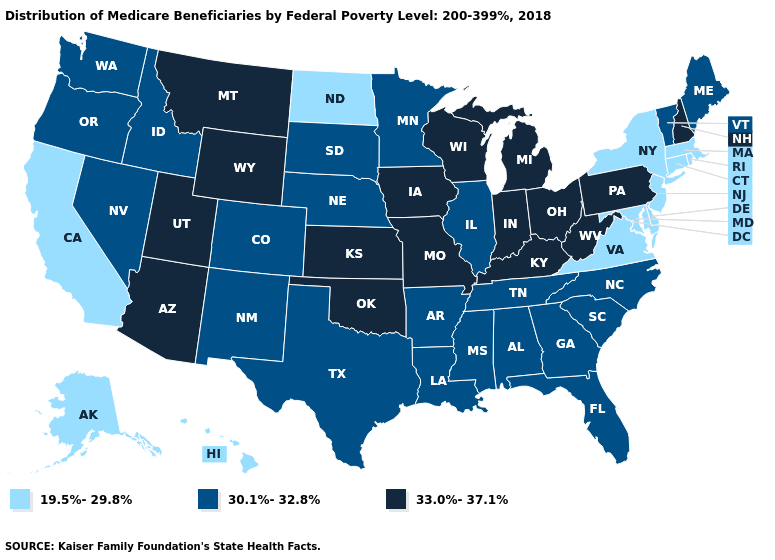Does North Dakota have the highest value in the MidWest?
Quick response, please. No. Name the states that have a value in the range 33.0%-37.1%?
Quick response, please. Arizona, Indiana, Iowa, Kansas, Kentucky, Michigan, Missouri, Montana, New Hampshire, Ohio, Oklahoma, Pennsylvania, Utah, West Virginia, Wisconsin, Wyoming. What is the value of Maryland?
Be succinct. 19.5%-29.8%. What is the value of Louisiana?
Short answer required. 30.1%-32.8%. What is the highest value in the USA?
Write a very short answer. 33.0%-37.1%. What is the value of Delaware?
Answer briefly. 19.5%-29.8%. Name the states that have a value in the range 33.0%-37.1%?
Answer briefly. Arizona, Indiana, Iowa, Kansas, Kentucky, Michigan, Missouri, Montana, New Hampshire, Ohio, Oklahoma, Pennsylvania, Utah, West Virginia, Wisconsin, Wyoming. Does Nebraska have a lower value than Pennsylvania?
Give a very brief answer. Yes. Does the map have missing data?
Be succinct. No. What is the value of Massachusetts?
Keep it brief. 19.5%-29.8%. Does Alabama have the lowest value in the USA?
Write a very short answer. No. Does the first symbol in the legend represent the smallest category?
Be succinct. Yes. Which states have the highest value in the USA?
Give a very brief answer. Arizona, Indiana, Iowa, Kansas, Kentucky, Michigan, Missouri, Montana, New Hampshire, Ohio, Oklahoma, Pennsylvania, Utah, West Virginia, Wisconsin, Wyoming. Which states hav the highest value in the MidWest?
Concise answer only. Indiana, Iowa, Kansas, Michigan, Missouri, Ohio, Wisconsin. 